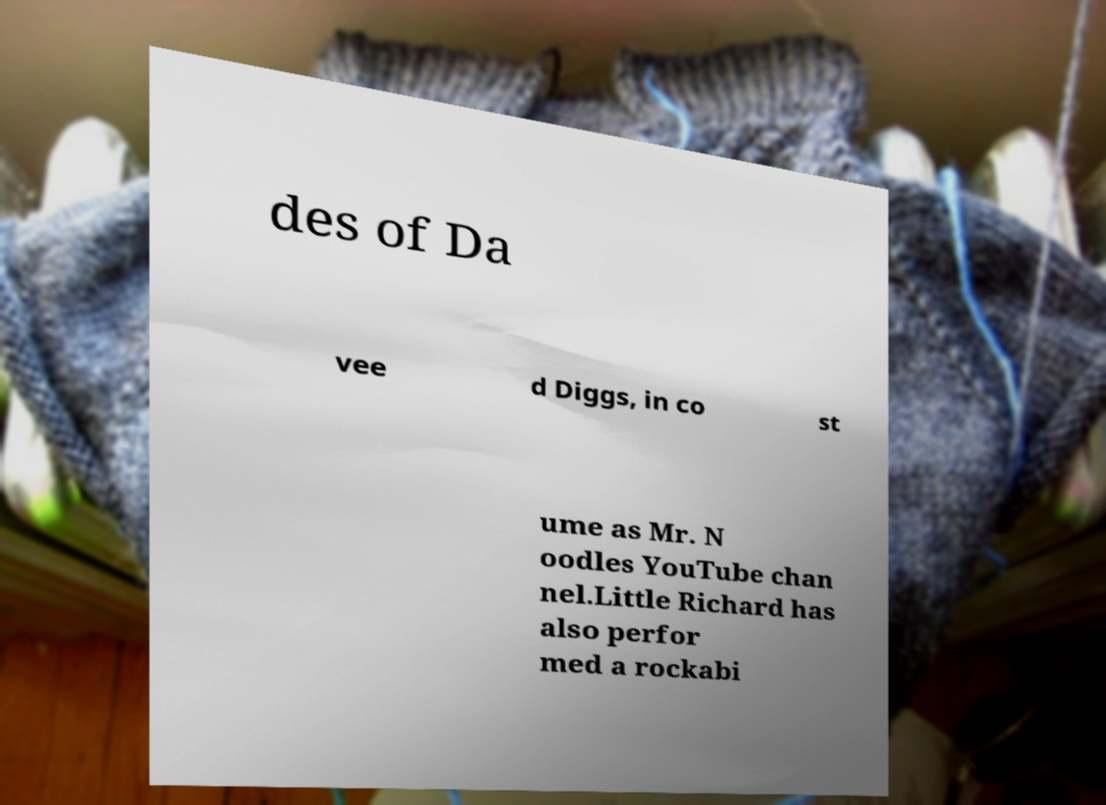Could you extract and type out the text from this image? des of Da vee d Diggs, in co st ume as Mr. N oodles YouTube chan nel.Little Richard has also perfor med a rockabi 